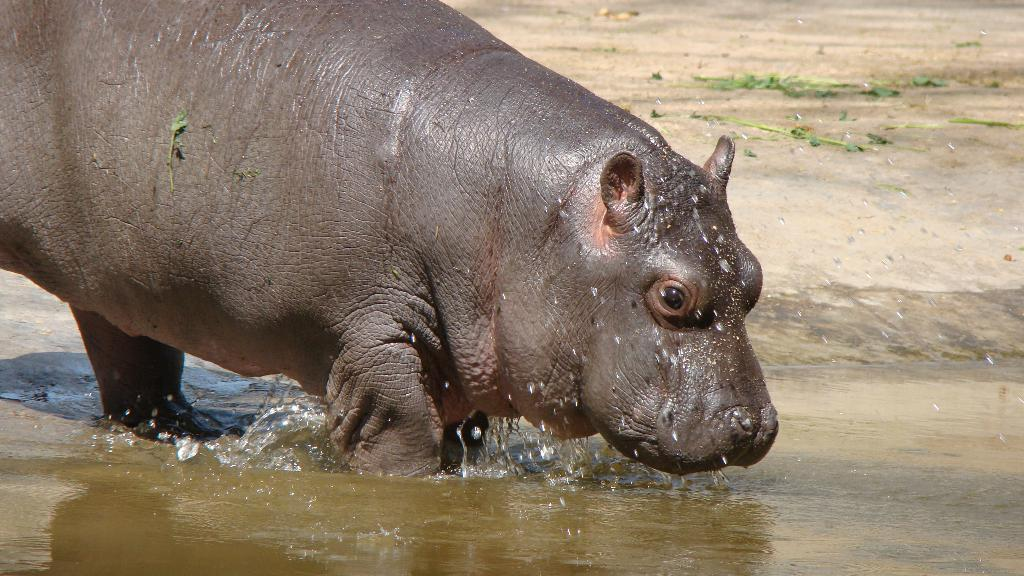What animal is present in the image? There is a hippopotamus in the image. Where is the hippopotamus located? The hippopotamus is in the water. What sound does the hippopotamus make while opening the drawer in the image? There is no drawer present in the image, and the hippopotamus is not making any sounds. 